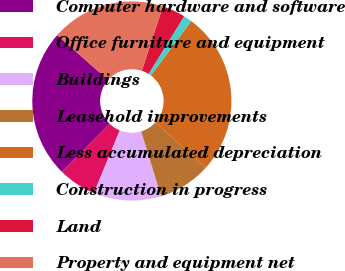<chart> <loc_0><loc_0><loc_500><loc_500><pie_chart><fcel>Computer hardware and software<fcel>Office furniture and equipment<fcel>Buildings<fcel>Leasehold improvements<fcel>Less accumulated depreciation<fcel>Construction in progress<fcel>Land<fcel>Property and equipment net<nl><fcel>24.14%<fcel>6.16%<fcel>10.96%<fcel>8.56%<fcel>26.54%<fcel>1.37%<fcel>3.76%<fcel>18.52%<nl></chart> 